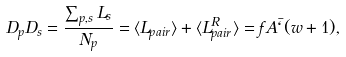<formula> <loc_0><loc_0><loc_500><loc_500>D _ { p } D _ { s } = \frac { \sum _ { p , s } { L _ { s } } } { N _ { p } } = \langle L _ { p a i r } \rangle + \langle L ^ { R } _ { p a i r } \rangle = f A \bar { \ell } ( w + 1 ) ,</formula> 